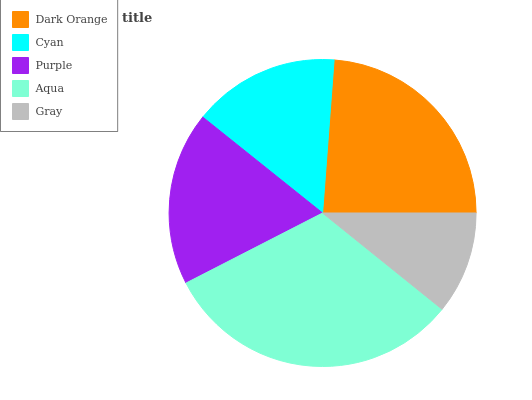Is Gray the minimum?
Answer yes or no. Yes. Is Aqua the maximum?
Answer yes or no. Yes. Is Cyan the minimum?
Answer yes or no. No. Is Cyan the maximum?
Answer yes or no. No. Is Dark Orange greater than Cyan?
Answer yes or no. Yes. Is Cyan less than Dark Orange?
Answer yes or no. Yes. Is Cyan greater than Dark Orange?
Answer yes or no. No. Is Dark Orange less than Cyan?
Answer yes or no. No. Is Purple the high median?
Answer yes or no. Yes. Is Purple the low median?
Answer yes or no. Yes. Is Gray the high median?
Answer yes or no. No. Is Gray the low median?
Answer yes or no. No. 